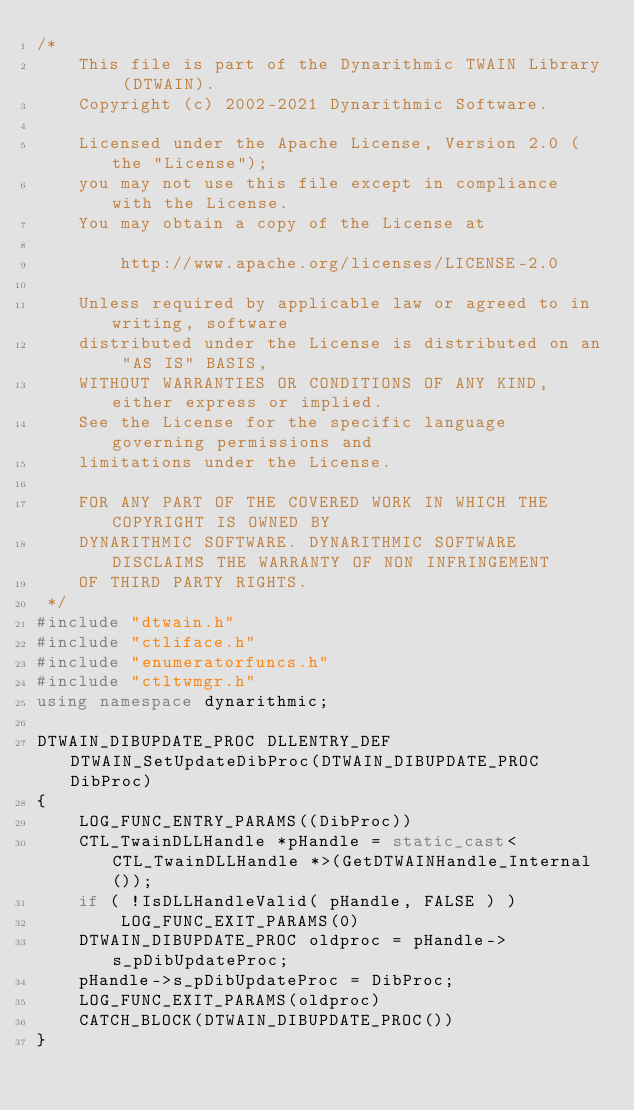Convert code to text. <code><loc_0><loc_0><loc_500><loc_500><_C++_>/*
    This file is part of the Dynarithmic TWAIN Library (DTWAIN).
    Copyright (c) 2002-2021 Dynarithmic Software.

    Licensed under the Apache License, Version 2.0 (the "License");
    you may not use this file except in compliance with the License.
    You may obtain a copy of the License at

        http://www.apache.org/licenses/LICENSE-2.0

    Unless required by applicable law or agreed to in writing, software
    distributed under the License is distributed on an "AS IS" BASIS,
    WITHOUT WARRANTIES OR CONDITIONS OF ANY KIND, either express or implied.
    See the License for the specific language governing permissions and
    limitations under the License.

    FOR ANY PART OF THE COVERED WORK IN WHICH THE COPYRIGHT IS OWNED BY
    DYNARITHMIC SOFTWARE. DYNARITHMIC SOFTWARE DISCLAIMS THE WARRANTY OF NON INFRINGEMENT
    OF THIRD PARTY RIGHTS.
 */
#include "dtwain.h"
#include "ctliface.h"
#include "enumeratorfuncs.h"
#include "ctltwmgr.h"
using namespace dynarithmic;

DTWAIN_DIBUPDATE_PROC DLLENTRY_DEF DTWAIN_SetUpdateDibProc(DTWAIN_DIBUPDATE_PROC DibProc)
{
    LOG_FUNC_ENTRY_PARAMS((DibProc))
    CTL_TwainDLLHandle *pHandle = static_cast<CTL_TwainDLLHandle *>(GetDTWAINHandle_Internal());
    if ( !IsDLLHandleValid( pHandle, FALSE ) )
        LOG_FUNC_EXIT_PARAMS(0)
    DTWAIN_DIBUPDATE_PROC oldproc = pHandle->s_pDibUpdateProc;
    pHandle->s_pDibUpdateProc = DibProc;
    LOG_FUNC_EXIT_PARAMS(oldproc)
    CATCH_BLOCK(DTWAIN_DIBUPDATE_PROC())
}
</code> 